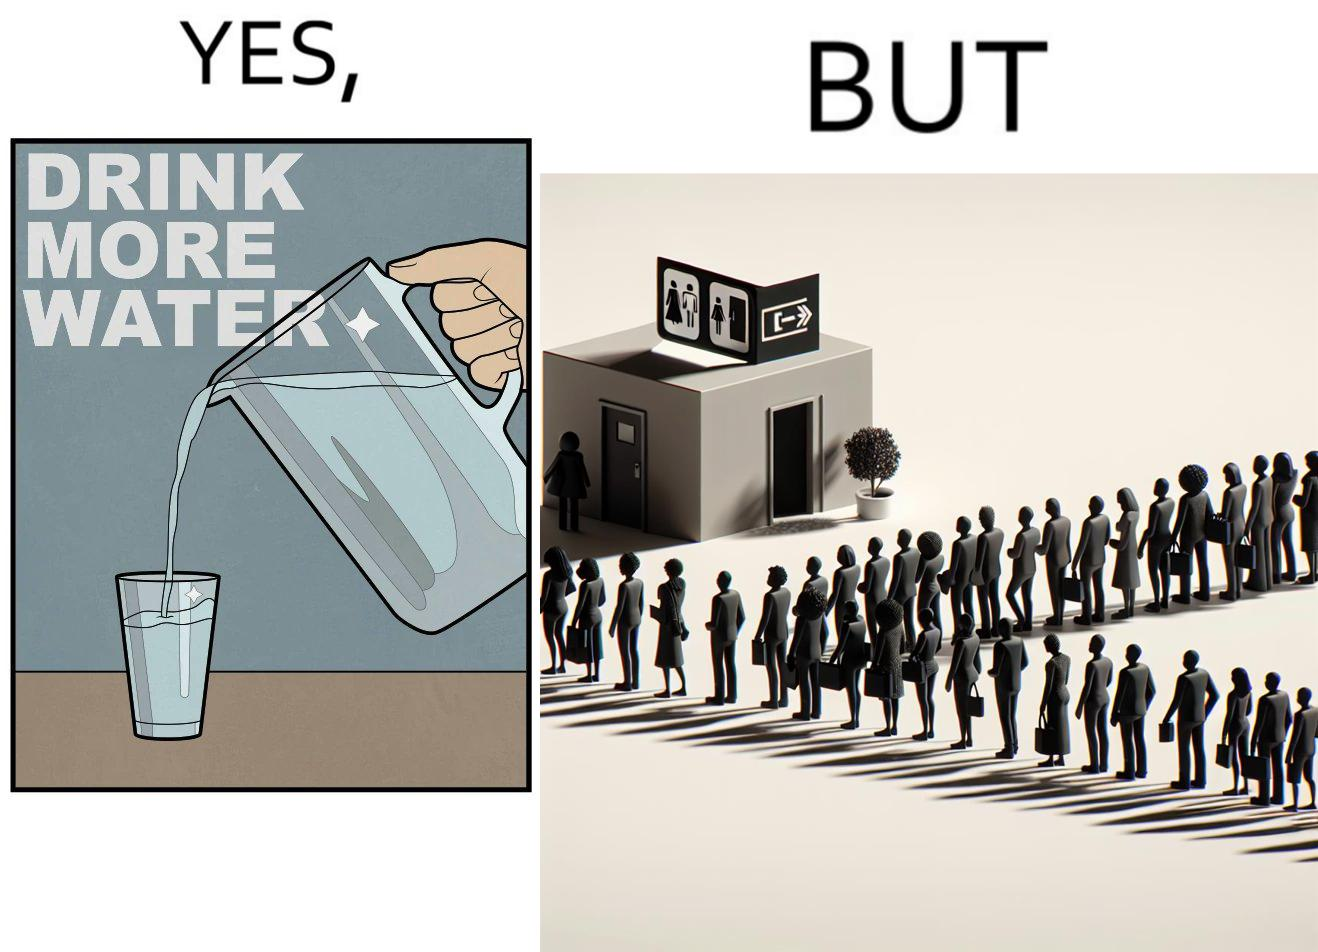Does this image contain satire or humor? Yes, this image is satirical. 